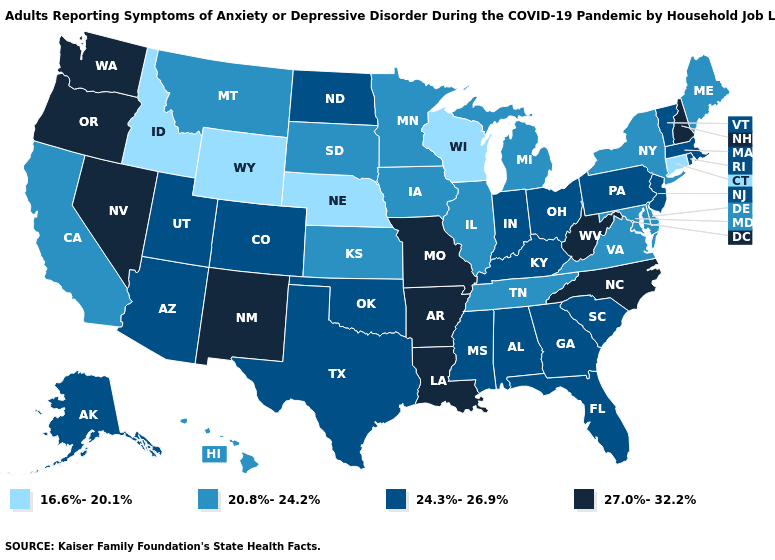Does Arizona have the same value as Montana?
Answer briefly. No. Does the map have missing data?
Quick response, please. No. Among the states that border Mississippi , does Tennessee have the lowest value?
Short answer required. Yes. What is the highest value in the Northeast ?
Be succinct. 27.0%-32.2%. Among the states that border Washington , which have the highest value?
Be succinct. Oregon. Name the states that have a value in the range 16.6%-20.1%?
Concise answer only. Connecticut, Idaho, Nebraska, Wisconsin, Wyoming. Among the states that border Pennsylvania , which have the highest value?
Concise answer only. West Virginia. What is the value of Idaho?
Short answer required. 16.6%-20.1%. What is the value of Idaho?
Short answer required. 16.6%-20.1%. What is the value of Virginia?
Short answer required. 20.8%-24.2%. What is the value of Massachusetts?
Keep it brief. 24.3%-26.9%. Among the states that border Louisiana , does Arkansas have the lowest value?
Answer briefly. No. Name the states that have a value in the range 24.3%-26.9%?
Quick response, please. Alabama, Alaska, Arizona, Colorado, Florida, Georgia, Indiana, Kentucky, Massachusetts, Mississippi, New Jersey, North Dakota, Ohio, Oklahoma, Pennsylvania, Rhode Island, South Carolina, Texas, Utah, Vermont. Name the states that have a value in the range 27.0%-32.2%?
Quick response, please. Arkansas, Louisiana, Missouri, Nevada, New Hampshire, New Mexico, North Carolina, Oregon, Washington, West Virginia. Among the states that border Mississippi , which have the highest value?
Be succinct. Arkansas, Louisiana. 